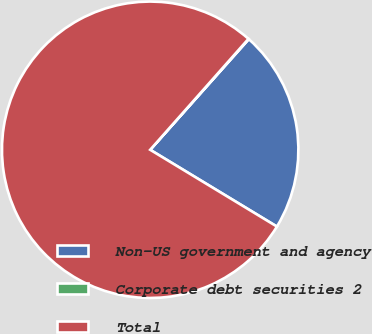<chart> <loc_0><loc_0><loc_500><loc_500><pie_chart><fcel>Non-US government and agency<fcel>Corporate debt securities 2<fcel>Total<nl><fcel>22.08%<fcel>0.05%<fcel>77.86%<nl></chart> 